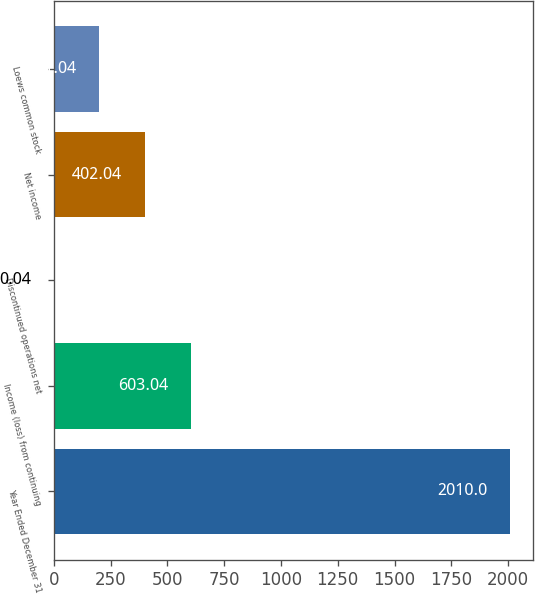<chart> <loc_0><loc_0><loc_500><loc_500><bar_chart><fcel>Year Ended December 31<fcel>Income (loss) from continuing<fcel>Discontinued operations net<fcel>Net income<fcel>Loews common stock<nl><fcel>2010<fcel>603.04<fcel>0.04<fcel>402.04<fcel>201.04<nl></chart> 